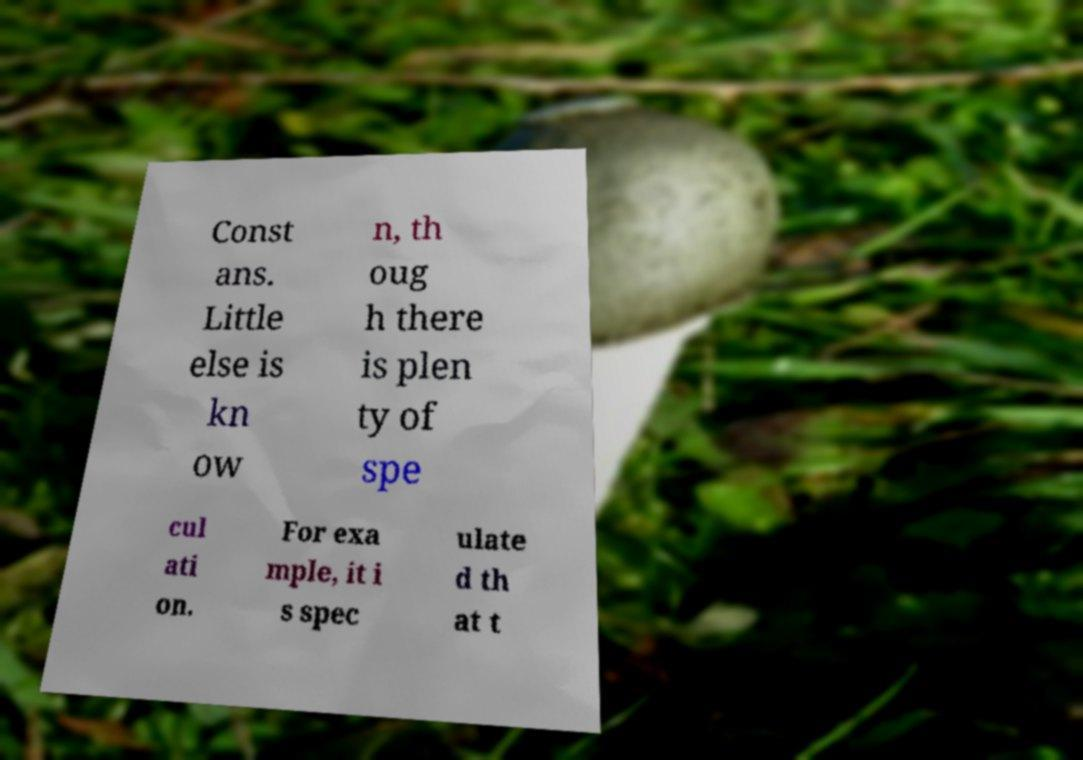I need the written content from this picture converted into text. Can you do that? Const ans. Little else is kn ow n, th oug h there is plen ty of spe cul ati on. For exa mple, it i s spec ulate d th at t 